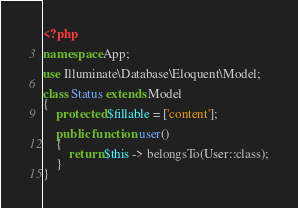Convert code to text. <code><loc_0><loc_0><loc_500><loc_500><_PHP_><?php

namespace App;

use Illuminate\Database\Eloquent\Model;

class Status extends Model
{
    protected $fillable = ['content'];

    public function user()
    {
        return $this -> belongsTo(User::class);
    }
}
</code> 